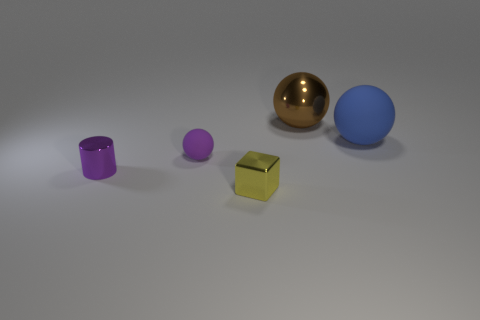Subtract all green balls. Subtract all cyan cubes. How many balls are left? 3 Subtract all green cylinders. How many blue blocks are left? 0 Add 4 yellows. How many small purples exist? 0 Subtract all small purple shiny objects. Subtract all brown metallic balls. How many objects are left? 3 Add 4 large blue spheres. How many large blue spheres are left? 5 Add 4 shiny spheres. How many shiny spheres exist? 5 Add 5 small green rubber cylinders. How many objects exist? 10 Subtract all brown spheres. How many spheres are left? 2 Subtract all matte spheres. How many spheres are left? 1 Subtract 0 red spheres. How many objects are left? 5 